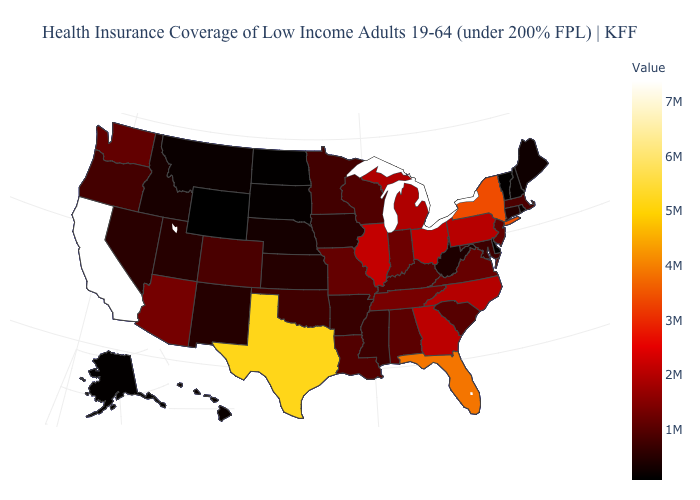Does Michigan have a lower value than California?
Short answer required. Yes. Is the legend a continuous bar?
Short answer required. Yes. Does the map have missing data?
Answer briefly. No. Does Indiana have a higher value than Pennsylvania?
Write a very short answer. No. Which states have the lowest value in the USA?
Quick response, please. Wyoming. Does Delaware have the lowest value in the South?
Write a very short answer. Yes. Does California have the highest value in the USA?
Write a very short answer. Yes. Does Oregon have the lowest value in the USA?
Write a very short answer. No. 